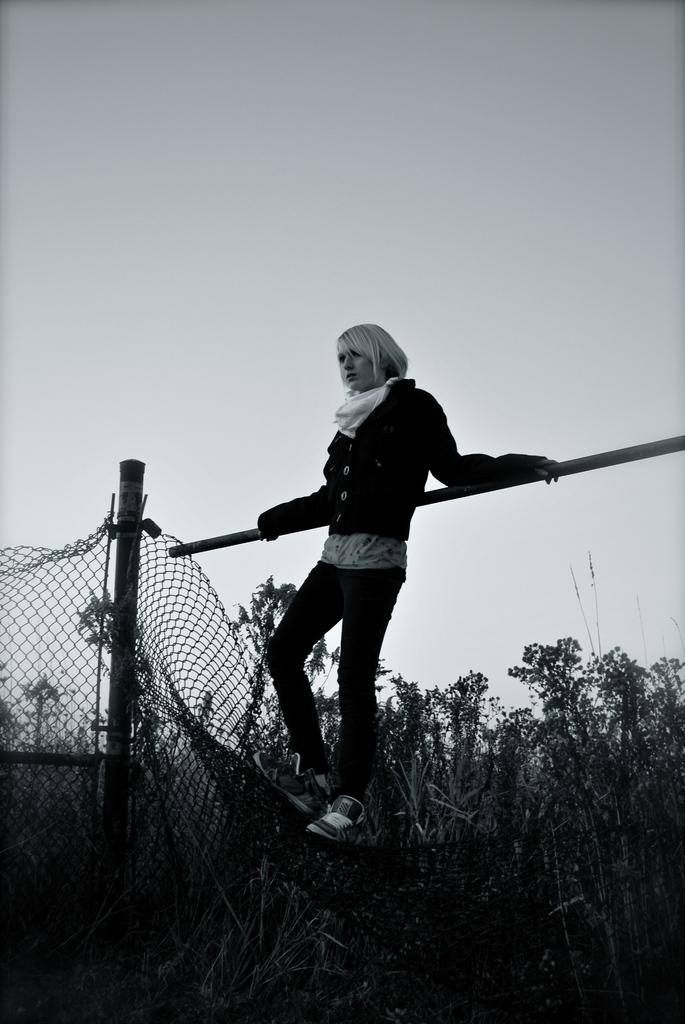What is the person in the image doing? The person is standing and holding an iron rod in the image. What can be seen in the image besides the person? There are plants, trees, a fence, and the sky visible in the image. What type of vegetation is present in the image? There are plants and trees in the image. What is the background of the image? The background of the image includes a fence and the sky. What year is the person in the image referring to when they mention respect? There is no mention of a year or respect in the image, so it is not possible to answer that question. 